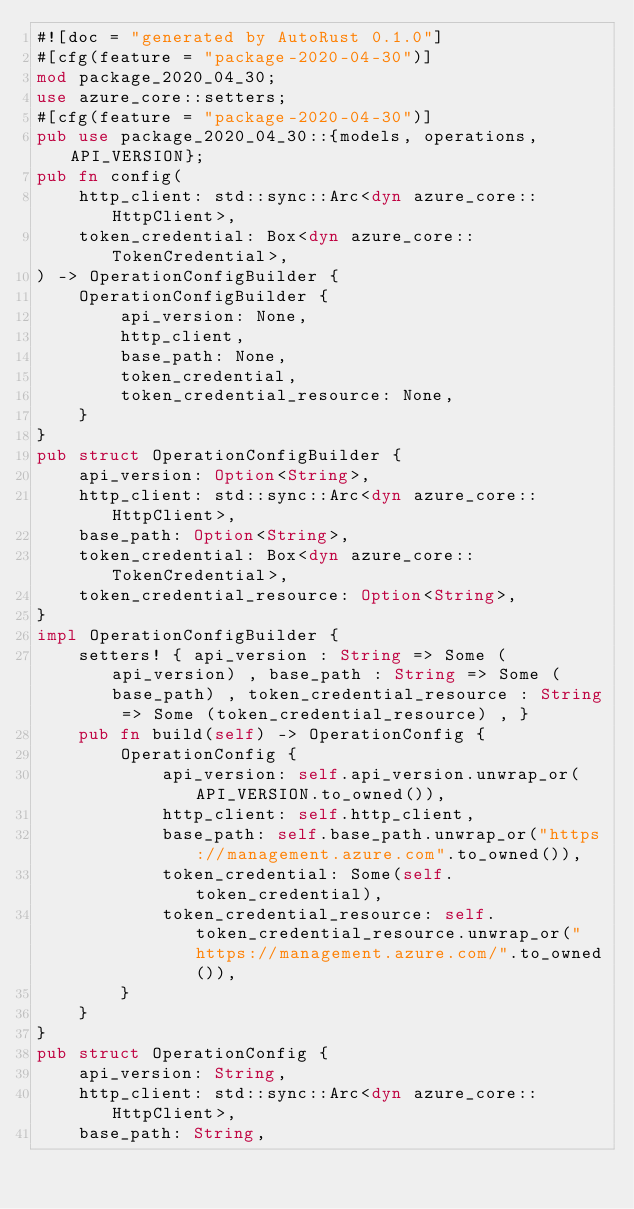<code> <loc_0><loc_0><loc_500><loc_500><_Rust_>#![doc = "generated by AutoRust 0.1.0"]
#[cfg(feature = "package-2020-04-30")]
mod package_2020_04_30;
use azure_core::setters;
#[cfg(feature = "package-2020-04-30")]
pub use package_2020_04_30::{models, operations, API_VERSION};
pub fn config(
    http_client: std::sync::Arc<dyn azure_core::HttpClient>,
    token_credential: Box<dyn azure_core::TokenCredential>,
) -> OperationConfigBuilder {
    OperationConfigBuilder {
        api_version: None,
        http_client,
        base_path: None,
        token_credential,
        token_credential_resource: None,
    }
}
pub struct OperationConfigBuilder {
    api_version: Option<String>,
    http_client: std::sync::Arc<dyn azure_core::HttpClient>,
    base_path: Option<String>,
    token_credential: Box<dyn azure_core::TokenCredential>,
    token_credential_resource: Option<String>,
}
impl OperationConfigBuilder {
    setters! { api_version : String => Some (api_version) , base_path : String => Some (base_path) , token_credential_resource : String => Some (token_credential_resource) , }
    pub fn build(self) -> OperationConfig {
        OperationConfig {
            api_version: self.api_version.unwrap_or(API_VERSION.to_owned()),
            http_client: self.http_client,
            base_path: self.base_path.unwrap_or("https://management.azure.com".to_owned()),
            token_credential: Some(self.token_credential),
            token_credential_resource: self.token_credential_resource.unwrap_or("https://management.azure.com/".to_owned()),
        }
    }
}
pub struct OperationConfig {
    api_version: String,
    http_client: std::sync::Arc<dyn azure_core::HttpClient>,
    base_path: String,</code> 